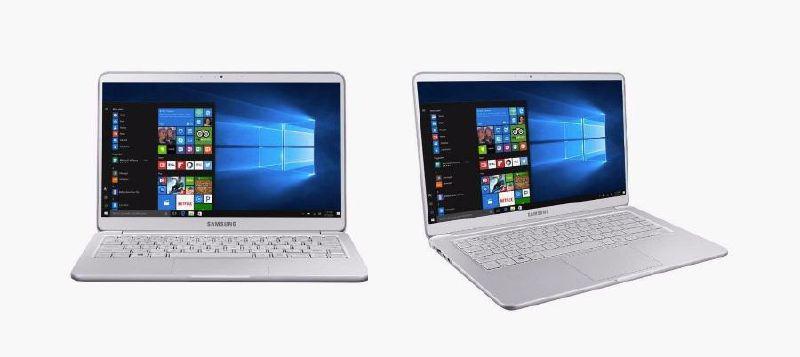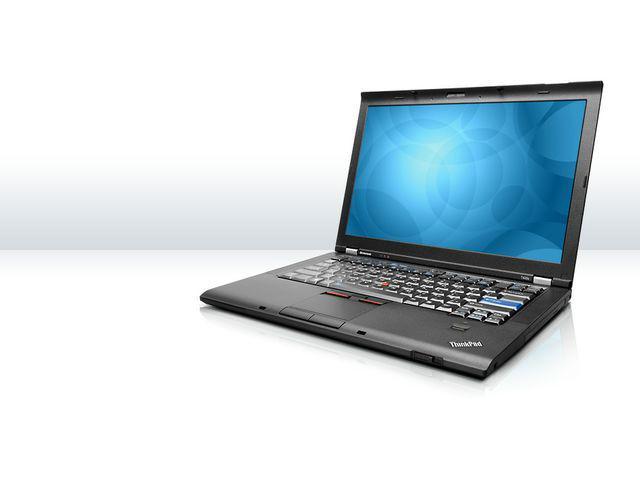The first image is the image on the left, the second image is the image on the right. Examine the images to the left and right. Is the description "There are three laptops in at least one of the images." accurate? Answer yes or no. No. The first image is the image on the left, the second image is the image on the right. Evaluate the accuracy of this statement regarding the images: "Exactly three computers are shown in the left image and all three computers are open with a design shown on the screen.". Is it true? Answer yes or no. No. 